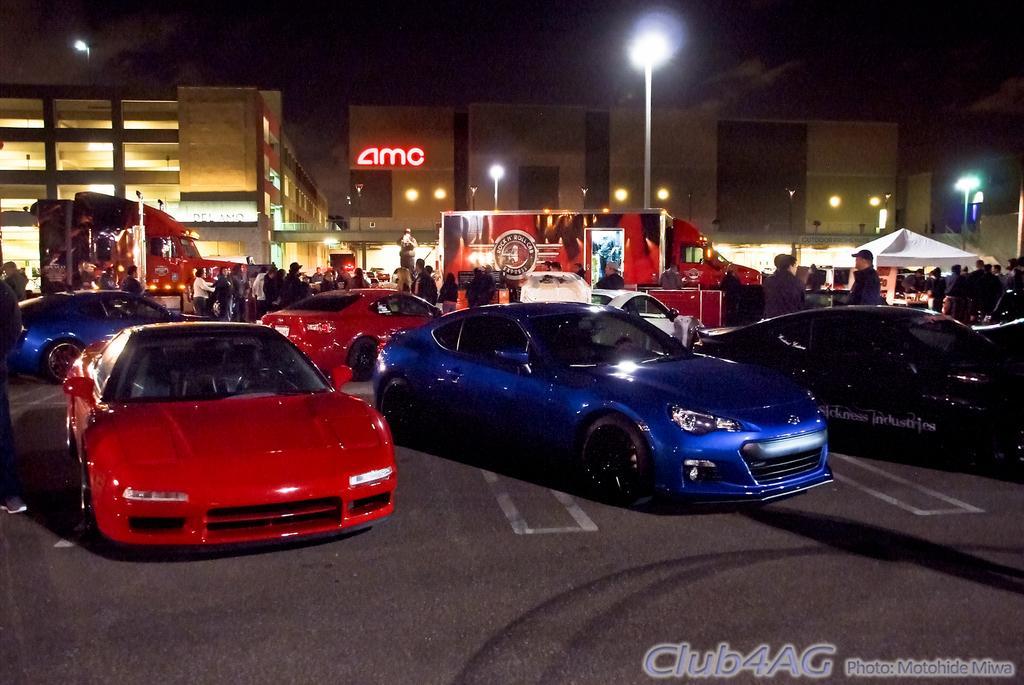How would you summarize this image in a sentence or two? These are the cars and trucks, which are parked. This looks like a canopy tent. I can see groups of people standing. These are the buildings with the lights. I can see the street lights. This looks like a name board, which is attached to the building. Here is the sky. At the bottom of the image, I can see the watermark. 